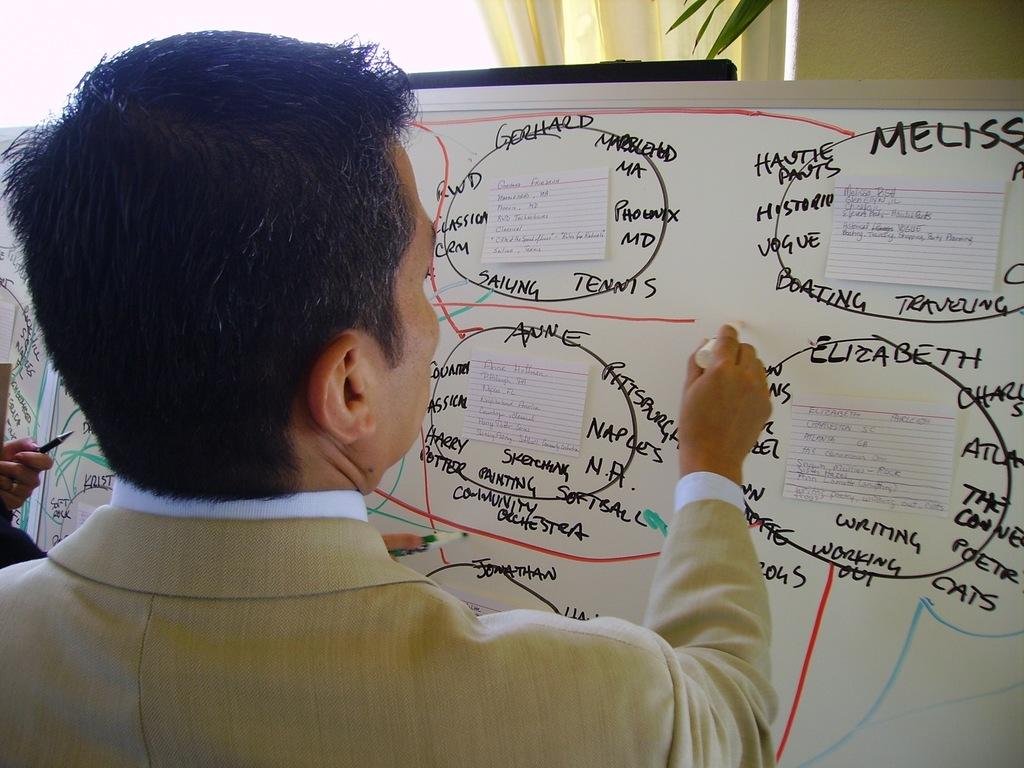Does elizabeth like working out?
Keep it short and to the point. Yes. 